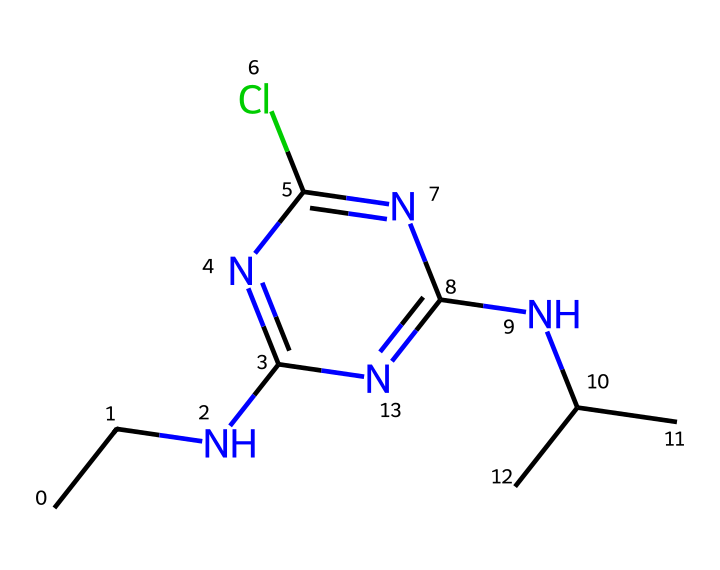What is the molecular formula of atrazine? To determine the molecular formula, we can count each type of atom present in the SMILES. The representation shows the presence of 9 carbon (C) atoms, 14 hydrogen (H) atoms, 2 nitrogen (N) atoms, and 1 chlorine (Cl) atom. Therefore, the molecular formula is C8H14ClN5.
Answer: C8H14ClN5 How many nitrogen atoms are in the atrazine structure? By examining the SMILES representation, we can see that there are 2 distinct nitrogen (N) atoms within the chemical structure.
Answer: 2 What functional groups are present in atrazine? Atrazine contains an amino group (-NH) and a chloro group (-Cl) as indicated by the presence of nitrogen and chlorine in the structure. The amino group contributes to its herbicidal activity.
Answer: amino and chloro Is atrazine a single compound or a mixture? The SMILES notation represents a single chemical structure, indicating that atrazine is a distinct and individual chemical compound, not a mixture.
Answer: single compound How many rings are present in the atrazine structure? The chemical structure shows one nitrogen-containing ring system, which identifies that one cyclic component is present in atrazine.
Answer: 1 What type of herbicide is atrazine classified as? Atrazine is classified as a triazine herbicide, which is characterized by its triazine ring structure that features alternating nitrogen and carbon.
Answer: triazine 